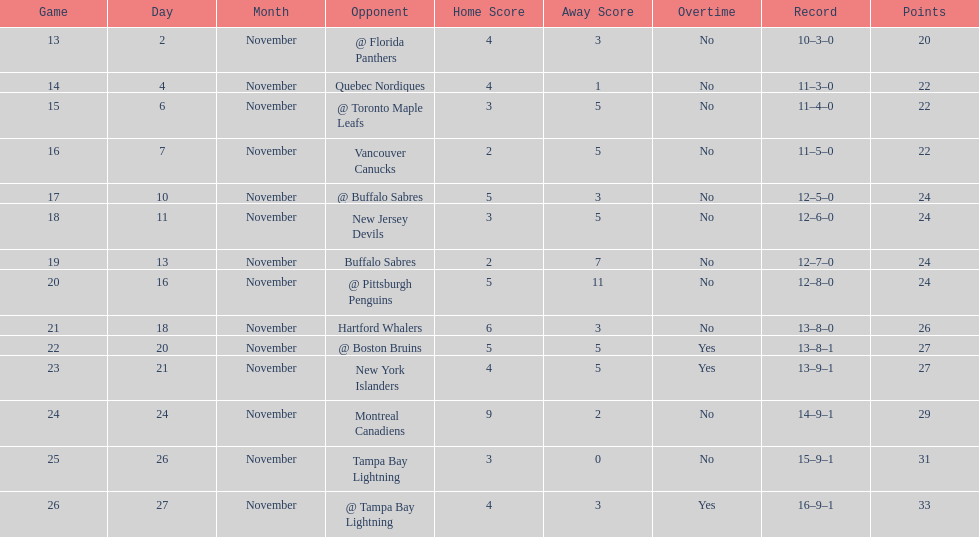The 1993-1994 flyers missed the playoffs again. how many consecutive seasons up until 93-94 did the flyers miss the playoffs? 5. 